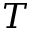<formula> <loc_0><loc_0><loc_500><loc_500>T</formula> 